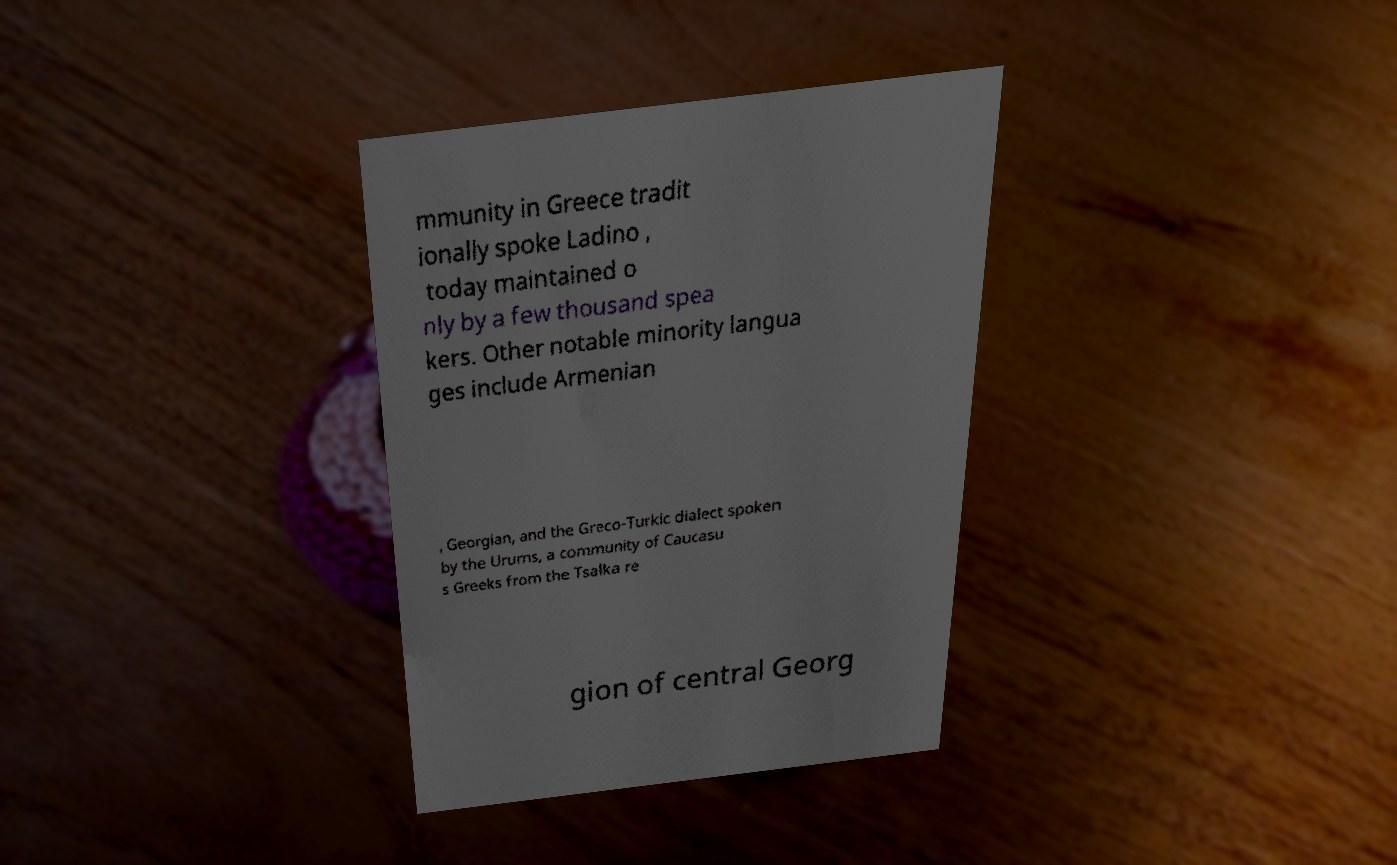Could you assist in decoding the text presented in this image and type it out clearly? mmunity in Greece tradit ionally spoke Ladino , today maintained o nly by a few thousand spea kers. Other notable minority langua ges include Armenian , Georgian, and the Greco-Turkic dialect spoken by the Urums, a community of Caucasu s Greeks from the Tsalka re gion of central Georg 